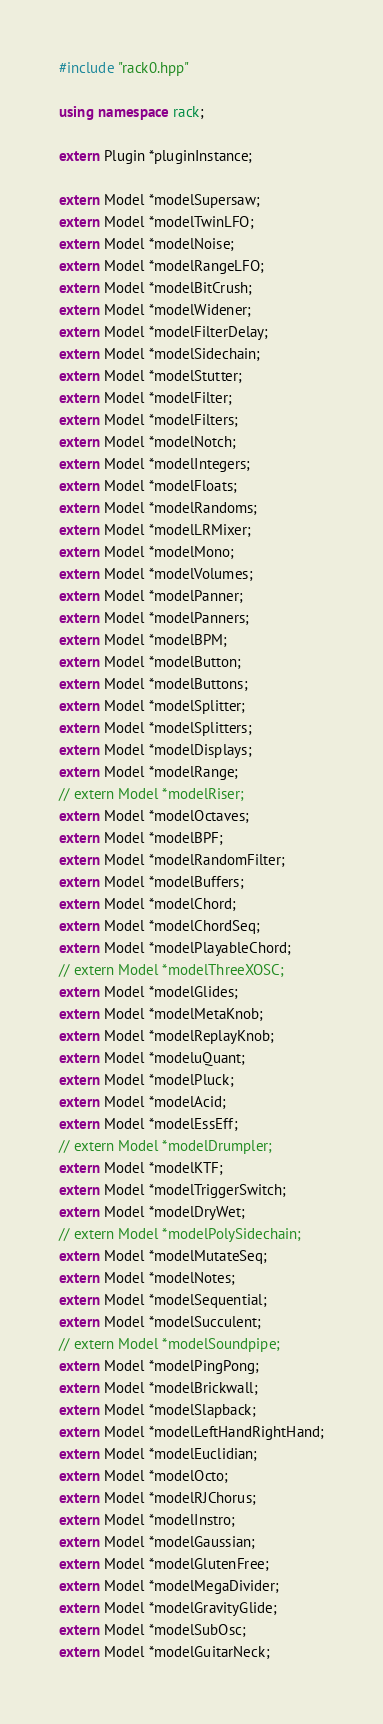<code> <loc_0><loc_0><loc_500><loc_500><_C++_>#include "rack0.hpp"

using namespace rack;

extern Plugin *pluginInstance;

extern Model *modelSupersaw;
extern Model *modelTwinLFO;
extern Model *modelNoise;
extern Model *modelRangeLFO;
extern Model *modelBitCrush;
extern Model *modelWidener;
extern Model *modelFilterDelay;
extern Model *modelSidechain;
extern Model *modelStutter;
extern Model *modelFilter;
extern Model *modelFilters;
extern Model *modelNotch;
extern Model *modelIntegers;
extern Model *modelFloats;
extern Model *modelRandoms;
extern Model *modelLRMixer;
extern Model *modelMono;
extern Model *modelVolumes;
extern Model *modelPanner;
extern Model *modelPanners;
extern Model *modelBPM;
extern Model *modelButton;
extern Model *modelButtons;
extern Model *modelSplitter;
extern Model *modelSplitters;
extern Model *modelDisplays;
extern Model *modelRange;
// extern Model *modelRiser;
extern Model *modelOctaves;
extern Model *modelBPF;
extern Model *modelRandomFilter;
extern Model *modelBuffers;
extern Model *modelChord;
extern Model *modelChordSeq;
extern Model *modelPlayableChord;
// extern Model *modelThreeXOSC;
extern Model *modelGlides;
extern Model *modelMetaKnob;
extern Model *modelReplayKnob;
extern Model *modeluQuant;
extern Model *modelPluck;
extern Model *modelAcid;
extern Model *modelEssEff;
// extern Model *modelDrumpler;
extern Model *modelKTF;
extern Model *modelTriggerSwitch;
extern Model *modelDryWet;
// extern Model *modelPolySidechain;
extern Model *modelMutateSeq;
extern Model *modelNotes;
extern Model *modelSequential;
extern Model *modelSucculent;
// extern Model *modelSoundpipe;
extern Model *modelPingPong;
extern Model *modelBrickwall;
extern Model *modelSlapback;
extern Model *modelLeftHandRightHand;
extern Model *modelEuclidian;
extern Model *modelOcto;
extern Model *modelRJChorus;
extern Model *modelInstro;
extern Model *modelGaussian;
extern Model *modelGlutenFree;
extern Model *modelMegaDivider;
extern Model *modelGravityGlide;
extern Model *modelSubOsc;
extern Model *modelGuitarNeck;
</code> 